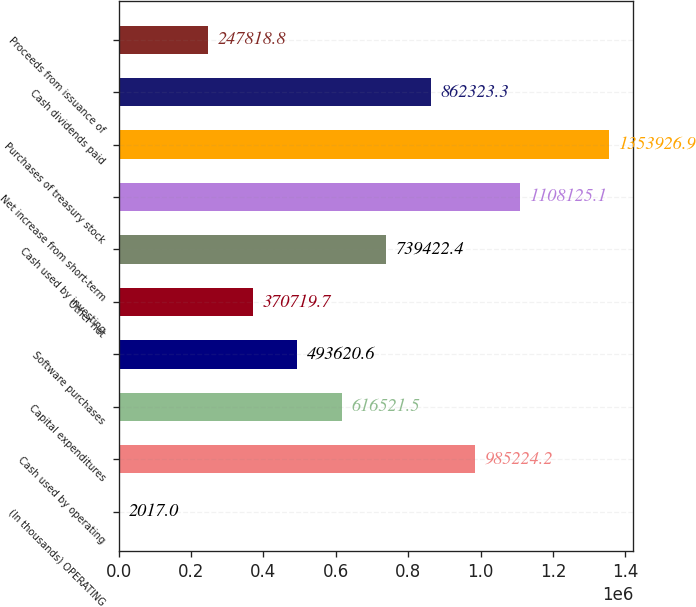<chart> <loc_0><loc_0><loc_500><loc_500><bar_chart><fcel>(In thousands) OPERATING<fcel>Cash used by operating<fcel>Capital expenditures<fcel>Software purchases<fcel>Other net<fcel>Cash used by investing<fcel>Net increase from short-term<fcel>Purchases of treasury stock<fcel>Cash dividends paid<fcel>Proceeds from issuance of<nl><fcel>2017<fcel>985224<fcel>616522<fcel>493621<fcel>370720<fcel>739422<fcel>1.10813e+06<fcel>1.35393e+06<fcel>862323<fcel>247819<nl></chart> 